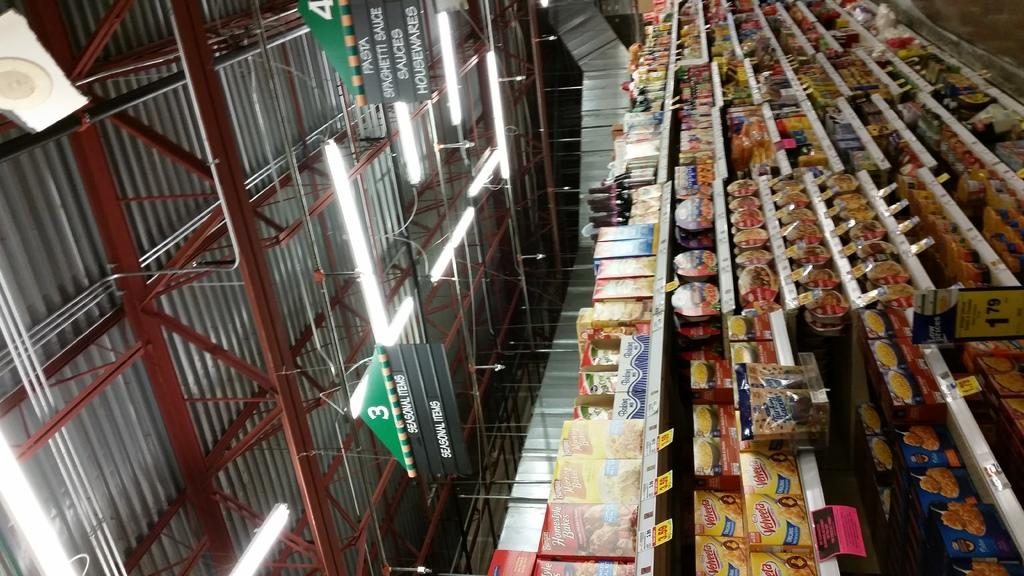<image>
Provide a brief description of the given image. Store aisle selling many foods for $1.79 and a sign saying Housewares. 